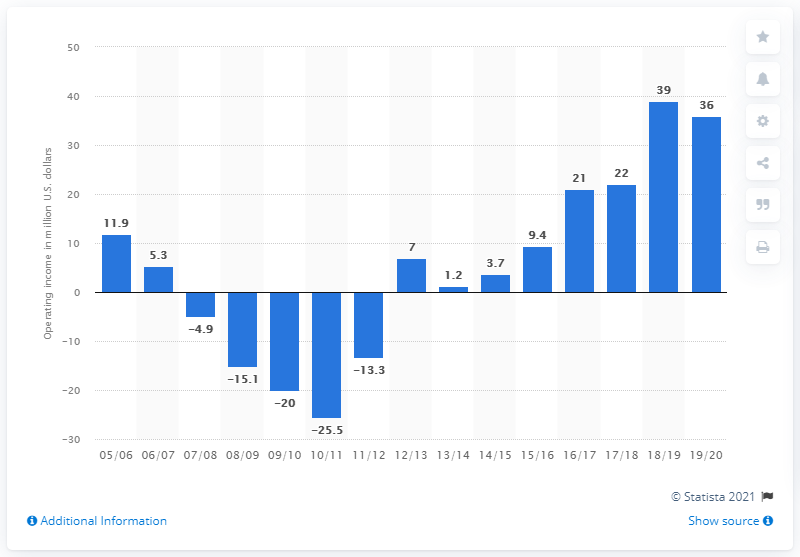Indicate a few pertinent items in this graphic. The operating income of the Charlotte Hornets in the 2019/20 season was approximately $3.6 million. 